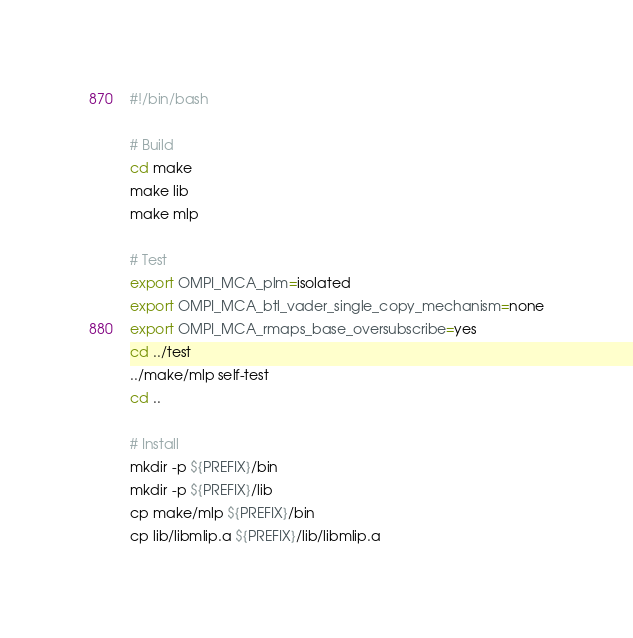Convert code to text. <code><loc_0><loc_0><loc_500><loc_500><_Bash_>#!/bin/bash

# Build 
cd make
make lib
make mlp

# Test 
export OMPI_MCA_plm=isolated
export OMPI_MCA_btl_vader_single_copy_mechanism=none
export OMPI_MCA_rmaps_base_oversubscribe=yes
cd ../test
../make/mlp self-test
cd ..

# Install
mkdir -p ${PREFIX}/bin
mkdir -p ${PREFIX}/lib
cp make/mlp ${PREFIX}/bin
cp lib/libmlip.a ${PREFIX}/lib/libmlip.a
</code> 